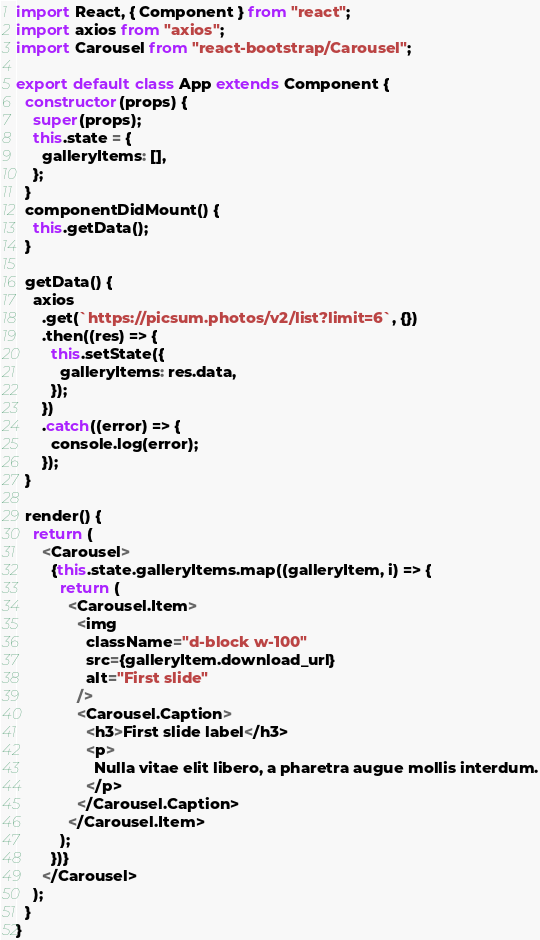<code> <loc_0><loc_0><loc_500><loc_500><_JavaScript_>import React, { Component } from "react";
import axios from "axios";
import Carousel from "react-bootstrap/Carousel";

export default class App extends Component {
  constructor(props) {
    super(props);
    this.state = {
      galleryItems: [],
    };
  }
  componentDidMount() {
    this.getData();
  }

  getData() {
    axios
      .get(`https://picsum.photos/v2/list?limit=6`, {})
      .then((res) => {
        this.setState({
          galleryItems: res.data,
        });
      })
      .catch((error) => {
        console.log(error);
      });
  }

  render() {
    return (
      <Carousel>
        {this.state.galleryItems.map((galleryItem, i) => {
          return (
            <Carousel.Item>
              <img
                className="d-block w-100"
                src={galleryItem.download_url}
                alt="First slide"
              />
              <Carousel.Caption>
                <h3>First slide label</h3>
                <p>
                  Nulla vitae elit libero, a pharetra augue mollis interdum.
                </p>
              </Carousel.Caption>
            </Carousel.Item>
          );
        })}
      </Carousel>
    );
  }
}
</code> 